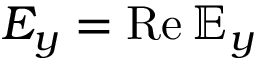Convert formula to latex. <formula><loc_0><loc_0><loc_500><loc_500>E _ { y } = R e \, { \mathbb { E } } _ { y }</formula> 